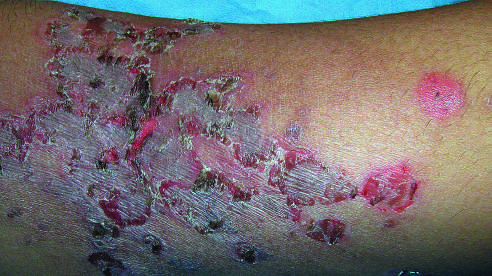s a child 's arm involved by a superficial bacterial infection showing the characteristic erythematous scablike lesions crusted with dried serum?
Answer the question using a single word or phrase. Yes 